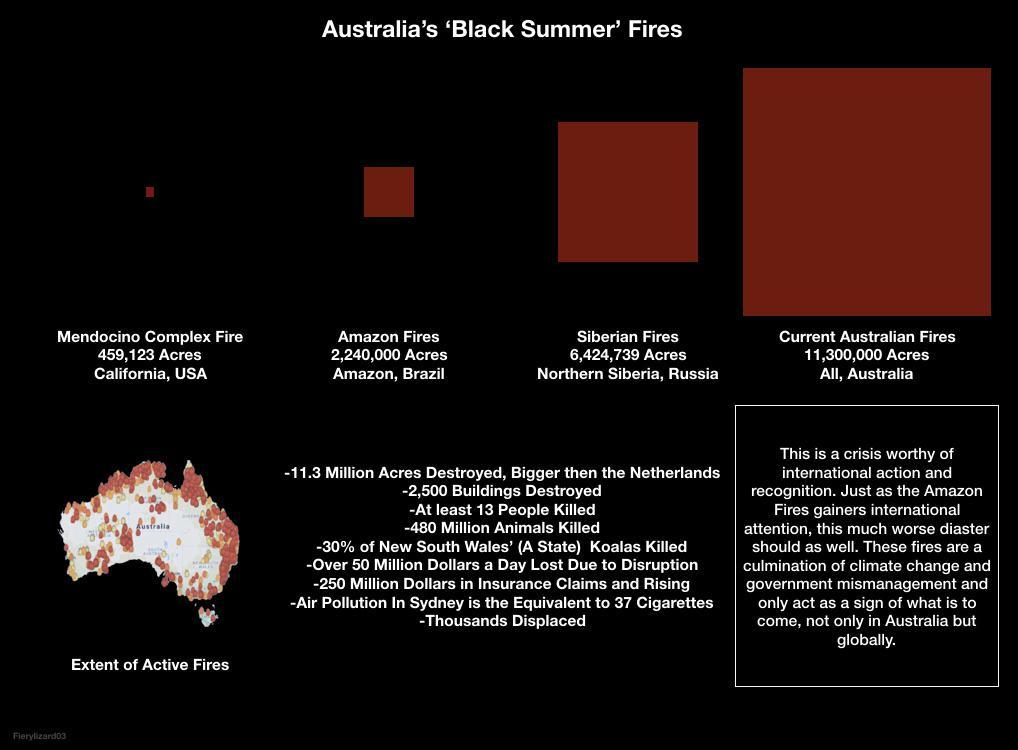Mention a couple of crucial points in this snapshot. The Amazon Fires destroyed approximately 2,240,000 acres of land. In Australia, 11,300,000 acres of land were destroyed by devastating wildfires. The land in Northern Siberia was destroyed by fire, resulting in the loss of 6,424,739 acres. A fire incident occurred in the state of California, specifically in the region known as Mendocino Complex, which resulted in significant damage. 